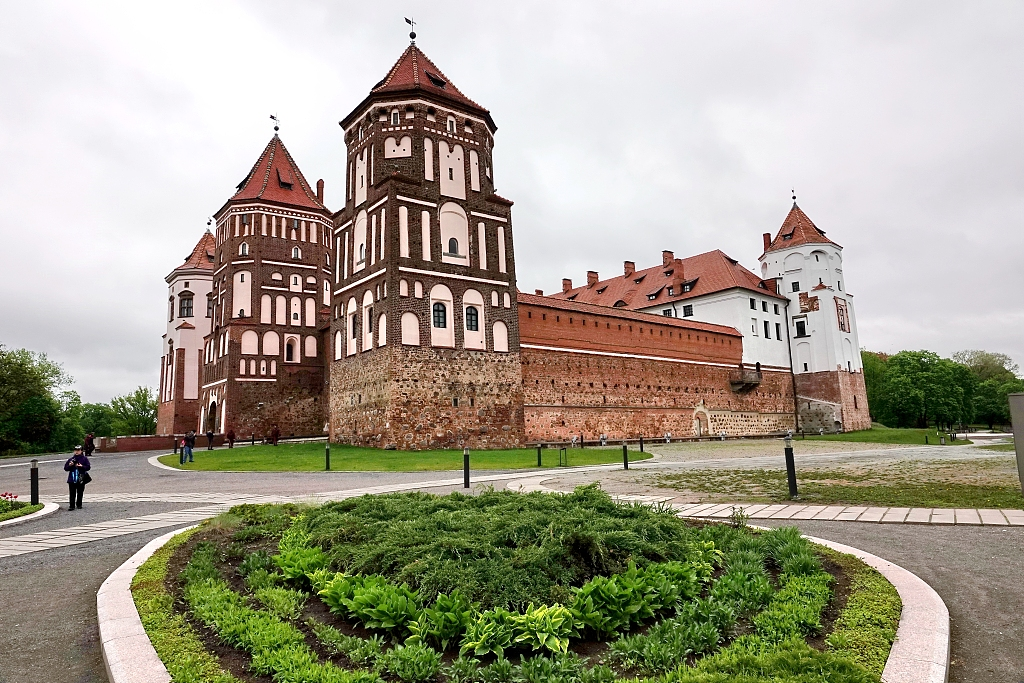What would it be like to host a modern-day wedding at Mir Castle? Hosting a modern-day wedding at Mir Castle would be nothing short of a fairytale experience. Guests would be captivated by the castle’s historic charm and majestic architecture. The ceremony could be held in the lush garden, under a floral arch with the castle as the stunning backdrop. The reception would take place in the grand halls, decorated with elegant flowers and twinkling lights, blending historical grandeur with modern elegance. The bride and groom would feel like royalty, walking through the sharegpt4v/same corridors as noble families of the past, while their guests would enjoy a unique and unforgettable celebration surrounded by centuries of history. 